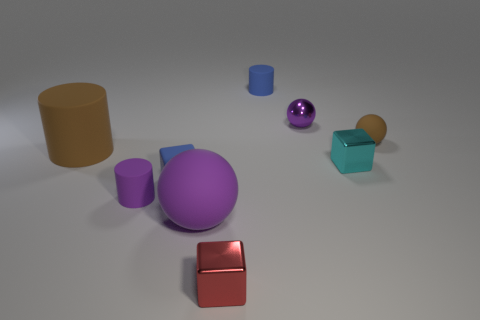Is the color of the big ball the same as the cylinder behind the big brown matte object?
Provide a short and direct response. No. What color is the small rubber thing that is the same shape as the big purple object?
Ensure brevity in your answer.  Brown. Does the brown cylinder have the same material as the small sphere left of the brown ball?
Keep it short and to the point. No. What is the color of the big matte ball?
Keep it short and to the point. Purple. There is a large cylinder that is behind the block on the left side of the sphere on the left side of the small blue cylinder; what is its color?
Provide a succinct answer. Brown. Does the small purple metallic object have the same shape as the tiny rubber object that is behind the small brown matte sphere?
Your answer should be compact. No. The matte object that is both on the left side of the small matte sphere and behind the big brown rubber cylinder is what color?
Provide a succinct answer. Blue. Are there any tiny matte things of the same shape as the red metallic thing?
Offer a terse response. Yes. Do the tiny metallic sphere and the tiny rubber cube have the same color?
Your answer should be compact. No. Are there any large rubber things that are behind the blue thing that is right of the tiny blue rubber cube?
Offer a terse response. No. 